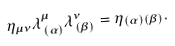<formula> <loc_0><loc_0><loc_500><loc_500>\eta _ { \mu \nu } \lambda ^ { \mu } _ { \, ( \alpha ) } \lambda ^ { \nu } _ { \, ( \beta ) } = \eta _ { ( \alpha ) ( \beta ) } .</formula> 